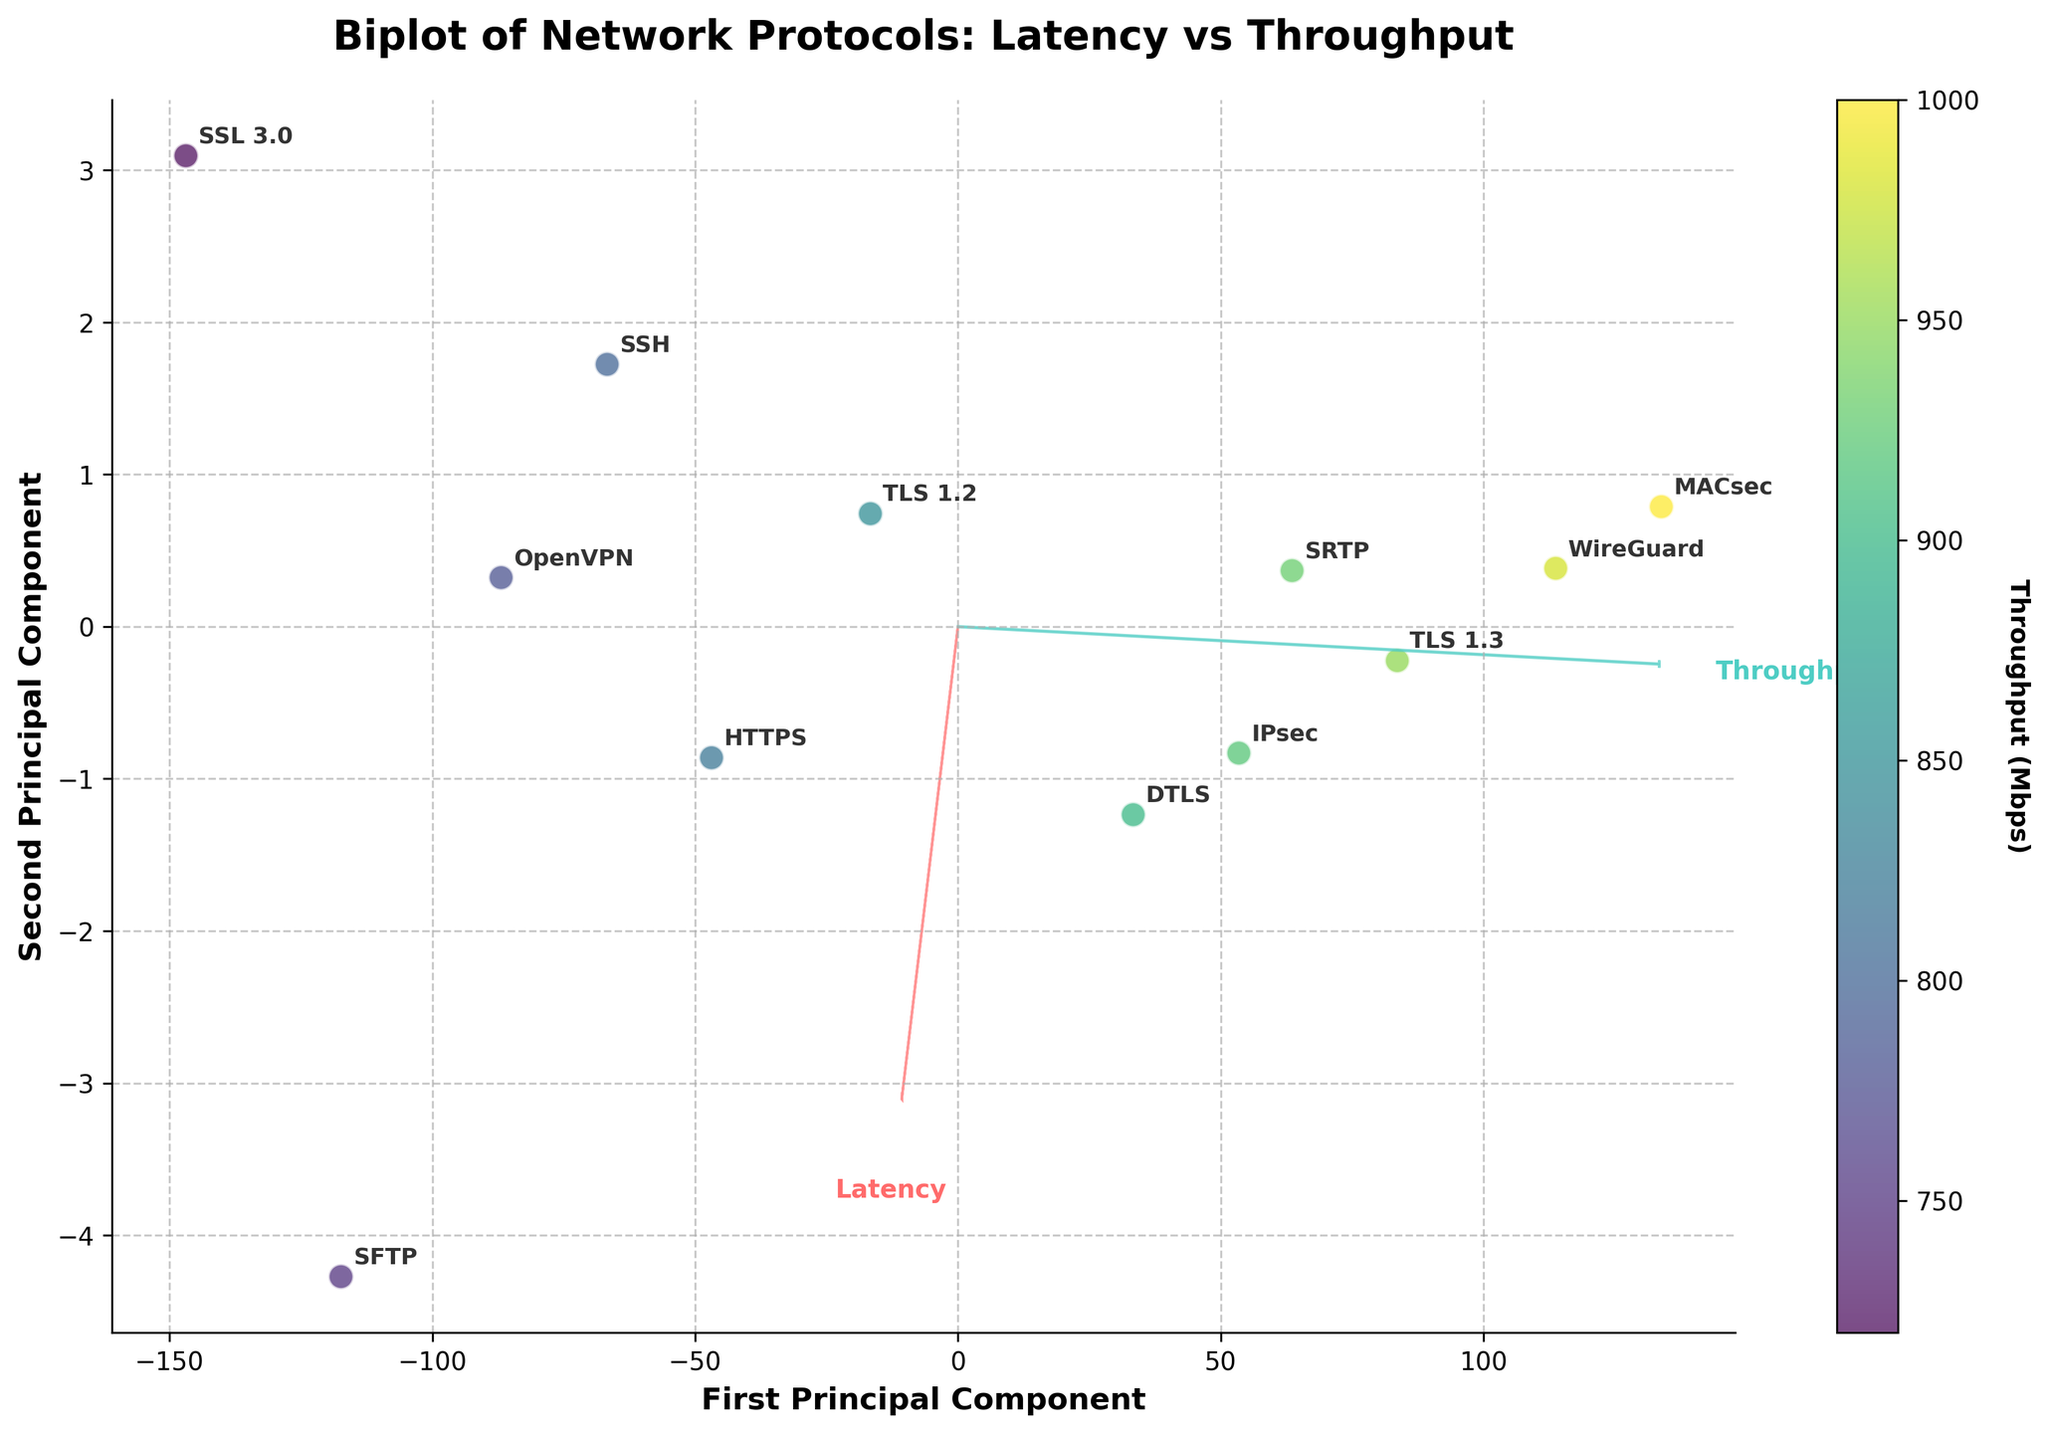What is the title of the plot? The title of the plot is prominently displayed at the top and reads "Biplot of Network Protocols: Latency vs Throughput".
Answer: Biplot of Network Protocols: Latency vs Throughput How many encryption protocols are visualized in the plot? Each protocol is annotated in the plot. By counting the individual annotations, we see there are 12 different protocols represented.
Answer: 12 Which protocol has the highest throughput? The color bar indicates higher throughput values in lighter shades. The label "MACsec" appears in the region with the lightest shade, signifying it has the highest throughput.
Answer: MACsec Which protocol has the lowest latency? The X value closer to the origin along the "Latency" vector represents lower latency. "MACsec" is closest in this direction, implying it has the lowest latency.
Answer: MACsec What are the names of the two principal components? The labels on the X and Y axes indicate the names of the principal components: "First Principal Component" and "Second Principal Component".
Answer: First Principal Component, Second Principal Component How does WireGuard compare to OpenVPN in terms of latency and throughput? WireGuard appears to the left of OpenVPN along the "Latency" vector, indicating lower latency. It also appears in a region with a lighter shade based on the color bar, indicating higher throughput.
Answer: Lower latency, higher throughput What does the vector direction signify in the biplot? The direction of the vectors represents the direction of increase for the respective features (Latency and Throughput). The arrow for "Latency" points towards higher latency, and the arrow for "Throughput" points towards higher throughput.
Answer: Direction of increase Can you identify a protocol with both high latency and low throughput? The protocols having high latency and low throughput are positioned far from the origin along "Latency" and in the regions with darker shades. "SFTP" satisfies both criteria.
Answer: SFTP Which protocols have a latency less than 20 ms based on their position relative to the latency vector? Protocols positioned closer to the origin along the "Latency" vector generally have less than 20 ms latency. These include MACsec, WireGuard, TLS 1.3, and SRTP.
Answer: MACsec, WireGuard, TLS 1.3, SRTP What can we infer about the relationship between latency and throughput from this biplot? The principal component vectors "Latency" and "Throughput" form an angle indicating they are not perfectly correlated. Observing the scatter plot, protocols with low latency generally tend to have higher throughput and vice versa, suggesting an inverse relationship.
Answer: Inverse relationship 